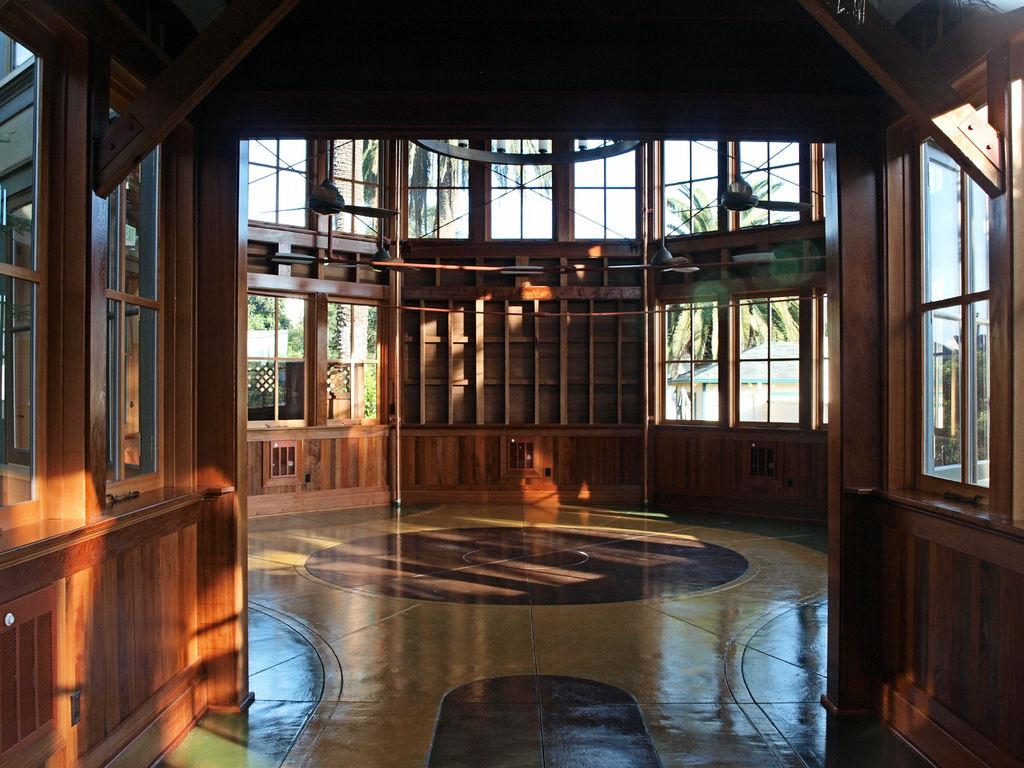What type of building is shown in the image? The image shows the inside view of a wooden building. Can you describe the interior of the building? Unfortunately, the provided facts do not give any information about the interior of the building. What is the chance of finding a line of parcel delivery trucks outside the building in the image? There is no information about the exterior of the building or the presence of parcel delivery trucks in the image, so we cannot determine the chance of finding them outside the building. 